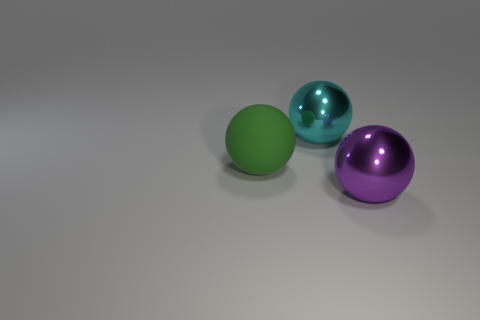Subtract all gray balls. Subtract all yellow cubes. How many balls are left? 3 Add 3 tiny rubber cubes. How many objects exist? 6 Add 1 large red metallic cylinders. How many large red metallic cylinders exist? 1 Subtract 0 purple cubes. How many objects are left? 3 Subtract all purple balls. Subtract all green things. How many objects are left? 1 Add 1 big green objects. How many big green objects are left? 2 